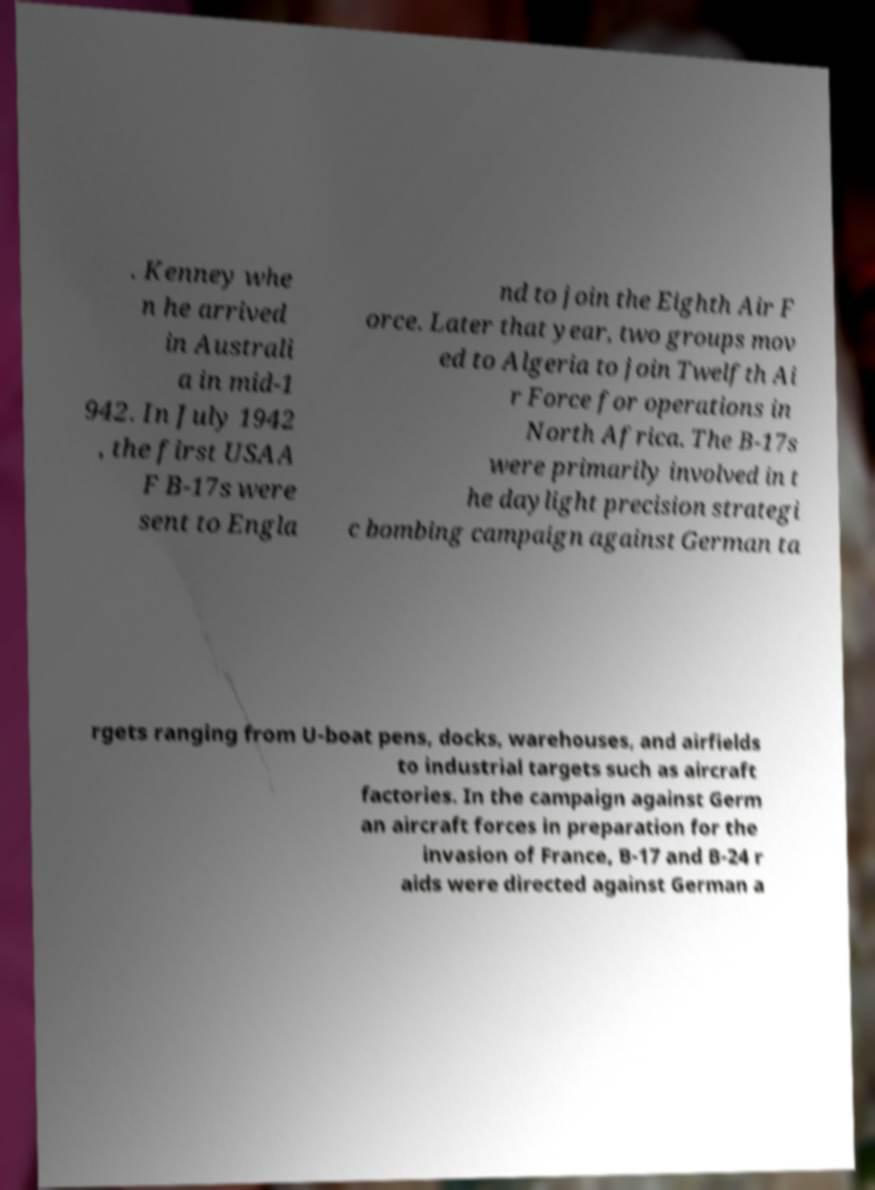Can you accurately transcribe the text from the provided image for me? . Kenney whe n he arrived in Australi a in mid-1 942. In July 1942 , the first USAA F B-17s were sent to Engla nd to join the Eighth Air F orce. Later that year, two groups mov ed to Algeria to join Twelfth Ai r Force for operations in North Africa. The B-17s were primarily involved in t he daylight precision strategi c bombing campaign against German ta rgets ranging from U-boat pens, docks, warehouses, and airfields to industrial targets such as aircraft factories. In the campaign against Germ an aircraft forces in preparation for the invasion of France, B-17 and B-24 r aids were directed against German a 